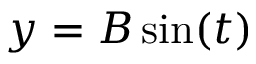Convert formula to latex. <formula><loc_0><loc_0><loc_500><loc_500>y = B \sin ( t )</formula> 